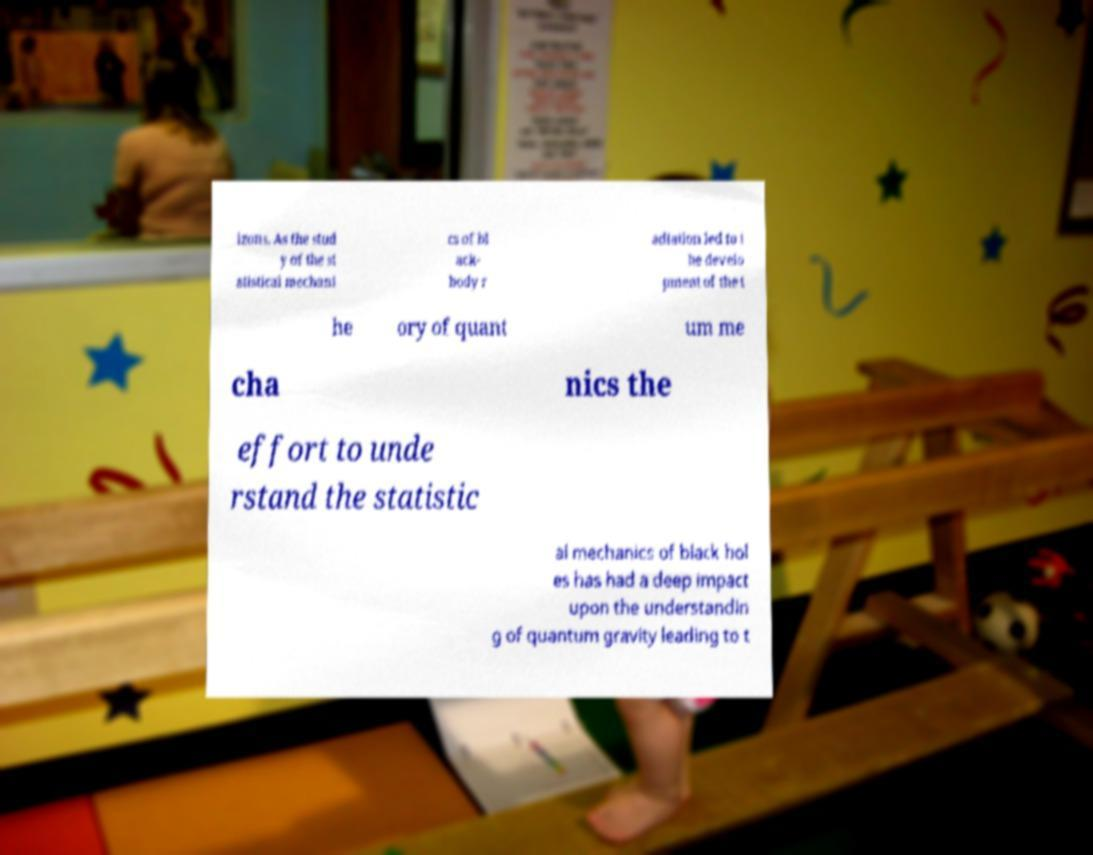Please read and relay the text visible in this image. What does it say? izons. As the stud y of the st atistical mechani cs of bl ack- body r adiation led to t he develo pment of the t he ory of quant um me cha nics the effort to unde rstand the statistic al mechanics of black hol es has had a deep impact upon the understandin g of quantum gravity leading to t 